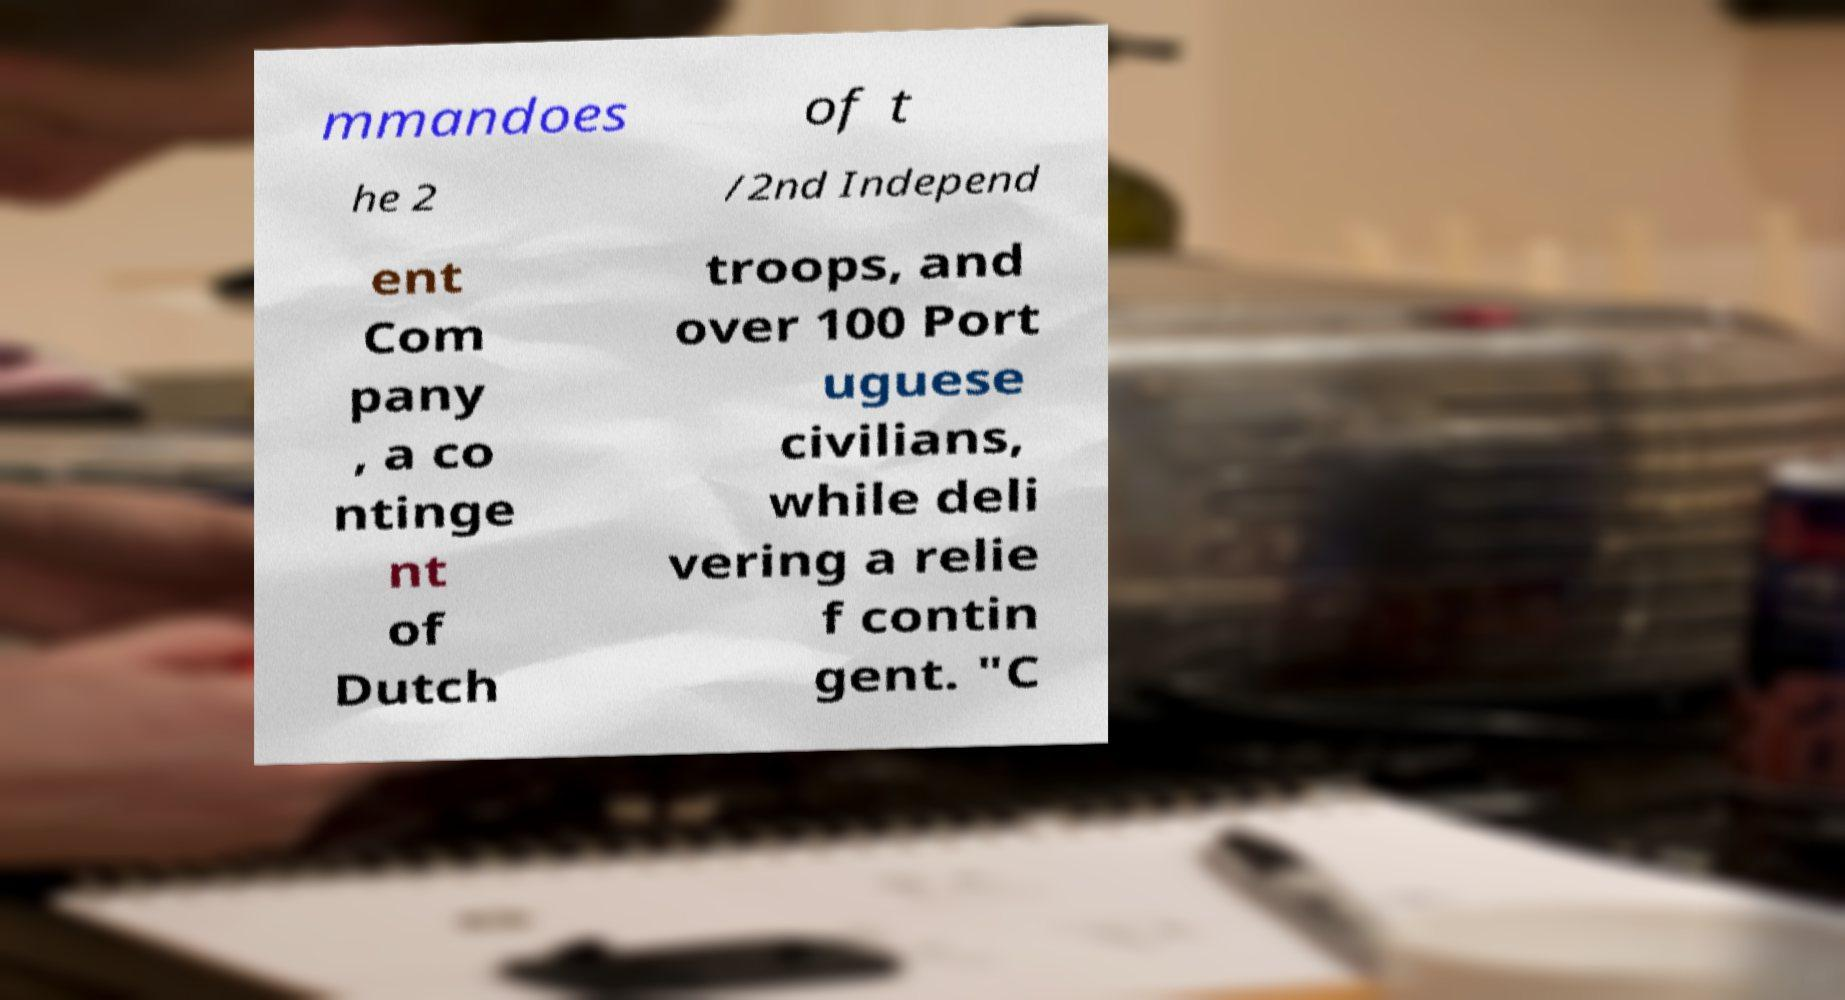I need the written content from this picture converted into text. Can you do that? mmandoes of t he 2 /2nd Independ ent Com pany , a co ntinge nt of Dutch troops, and over 100 Port uguese civilians, while deli vering a relie f contin gent. "C 